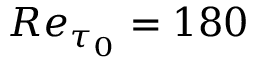Convert formula to latex. <formula><loc_0><loc_0><loc_500><loc_500>R e _ { \tau _ { 0 } } = 1 8 0</formula> 